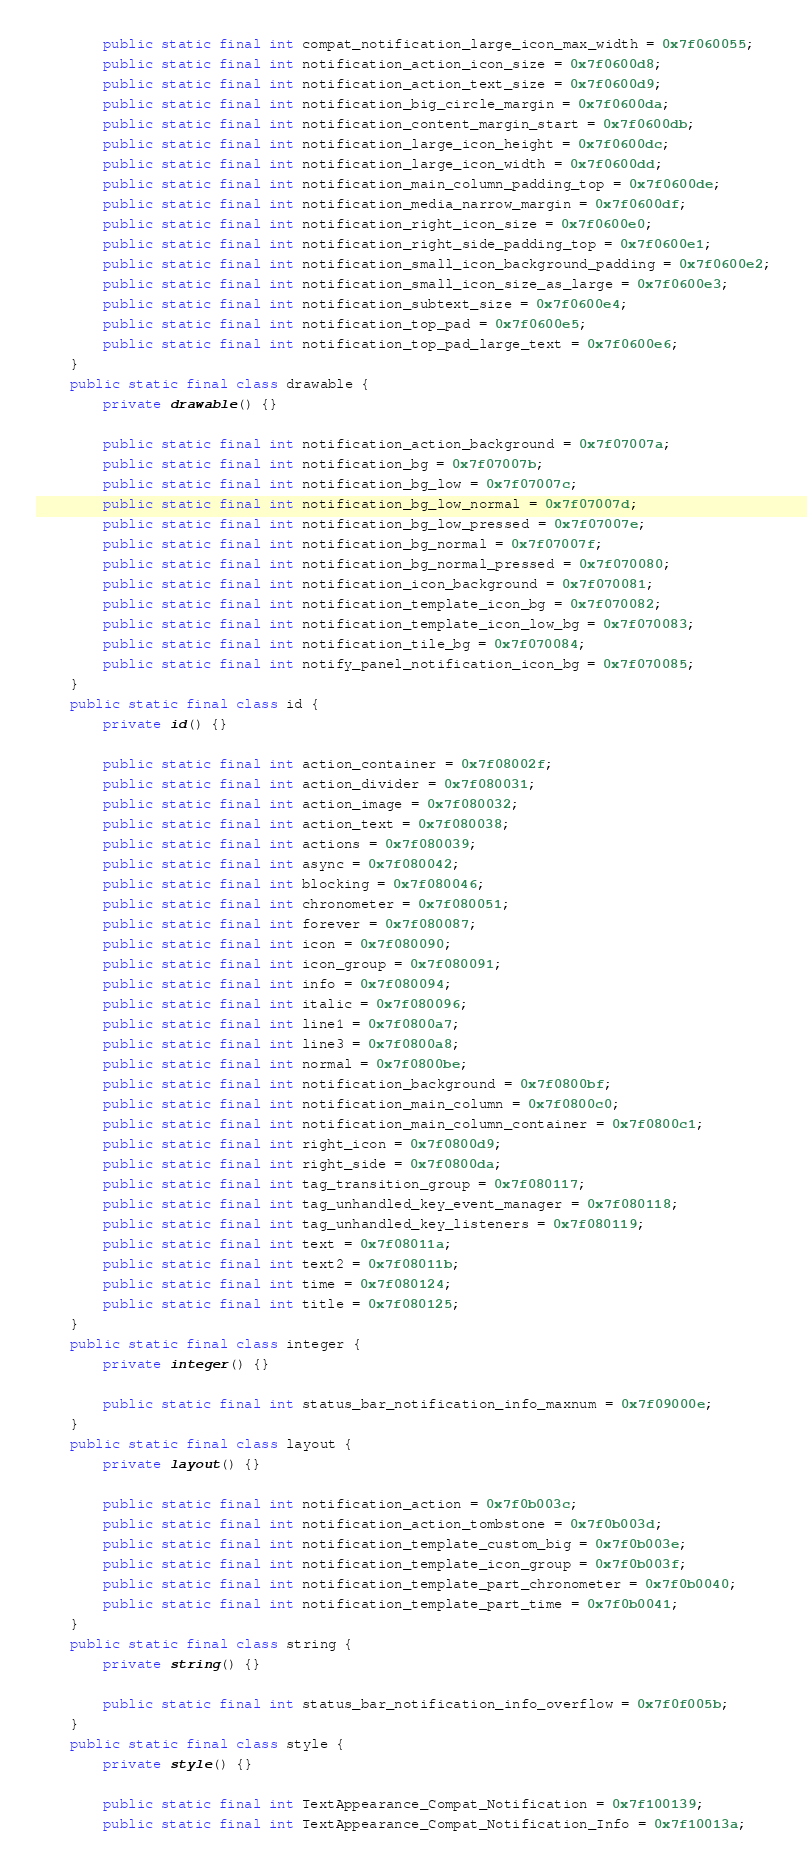Convert code to text. <code><loc_0><loc_0><loc_500><loc_500><_Java_>        public static final int compat_notification_large_icon_max_width = 0x7f060055;
        public static final int notification_action_icon_size = 0x7f0600d8;
        public static final int notification_action_text_size = 0x7f0600d9;
        public static final int notification_big_circle_margin = 0x7f0600da;
        public static final int notification_content_margin_start = 0x7f0600db;
        public static final int notification_large_icon_height = 0x7f0600dc;
        public static final int notification_large_icon_width = 0x7f0600dd;
        public static final int notification_main_column_padding_top = 0x7f0600de;
        public static final int notification_media_narrow_margin = 0x7f0600df;
        public static final int notification_right_icon_size = 0x7f0600e0;
        public static final int notification_right_side_padding_top = 0x7f0600e1;
        public static final int notification_small_icon_background_padding = 0x7f0600e2;
        public static final int notification_small_icon_size_as_large = 0x7f0600e3;
        public static final int notification_subtext_size = 0x7f0600e4;
        public static final int notification_top_pad = 0x7f0600e5;
        public static final int notification_top_pad_large_text = 0x7f0600e6;
    }
    public static final class drawable {
        private drawable() {}

        public static final int notification_action_background = 0x7f07007a;
        public static final int notification_bg = 0x7f07007b;
        public static final int notification_bg_low = 0x7f07007c;
        public static final int notification_bg_low_normal = 0x7f07007d;
        public static final int notification_bg_low_pressed = 0x7f07007e;
        public static final int notification_bg_normal = 0x7f07007f;
        public static final int notification_bg_normal_pressed = 0x7f070080;
        public static final int notification_icon_background = 0x7f070081;
        public static final int notification_template_icon_bg = 0x7f070082;
        public static final int notification_template_icon_low_bg = 0x7f070083;
        public static final int notification_tile_bg = 0x7f070084;
        public static final int notify_panel_notification_icon_bg = 0x7f070085;
    }
    public static final class id {
        private id() {}

        public static final int action_container = 0x7f08002f;
        public static final int action_divider = 0x7f080031;
        public static final int action_image = 0x7f080032;
        public static final int action_text = 0x7f080038;
        public static final int actions = 0x7f080039;
        public static final int async = 0x7f080042;
        public static final int blocking = 0x7f080046;
        public static final int chronometer = 0x7f080051;
        public static final int forever = 0x7f080087;
        public static final int icon = 0x7f080090;
        public static final int icon_group = 0x7f080091;
        public static final int info = 0x7f080094;
        public static final int italic = 0x7f080096;
        public static final int line1 = 0x7f0800a7;
        public static final int line3 = 0x7f0800a8;
        public static final int normal = 0x7f0800be;
        public static final int notification_background = 0x7f0800bf;
        public static final int notification_main_column = 0x7f0800c0;
        public static final int notification_main_column_container = 0x7f0800c1;
        public static final int right_icon = 0x7f0800d9;
        public static final int right_side = 0x7f0800da;
        public static final int tag_transition_group = 0x7f080117;
        public static final int tag_unhandled_key_event_manager = 0x7f080118;
        public static final int tag_unhandled_key_listeners = 0x7f080119;
        public static final int text = 0x7f08011a;
        public static final int text2 = 0x7f08011b;
        public static final int time = 0x7f080124;
        public static final int title = 0x7f080125;
    }
    public static final class integer {
        private integer() {}

        public static final int status_bar_notification_info_maxnum = 0x7f09000e;
    }
    public static final class layout {
        private layout() {}

        public static final int notification_action = 0x7f0b003c;
        public static final int notification_action_tombstone = 0x7f0b003d;
        public static final int notification_template_custom_big = 0x7f0b003e;
        public static final int notification_template_icon_group = 0x7f0b003f;
        public static final int notification_template_part_chronometer = 0x7f0b0040;
        public static final int notification_template_part_time = 0x7f0b0041;
    }
    public static final class string {
        private string() {}

        public static final int status_bar_notification_info_overflow = 0x7f0f005b;
    }
    public static final class style {
        private style() {}

        public static final int TextAppearance_Compat_Notification = 0x7f100139;
        public static final int TextAppearance_Compat_Notification_Info = 0x7f10013a;</code> 